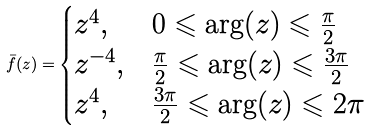<formula> <loc_0><loc_0><loc_500><loc_500>\bar { f } ( z ) = \begin{cases} z ^ { 4 } , & \text {$0\leqslant \arg(z)\leqslant \frac{\pi}{2}$} \\ z ^ { - 4 } , & \text {$\frac{\pi}{2}\leqslant \arg(z)\leqslant \frac{3\pi}{2}$} \\ z ^ { 4 } , & \text {$\frac{3\pi}{2}\leqslant \arg(z)\leqslant 2\pi $} \\ \end{cases}</formula> 